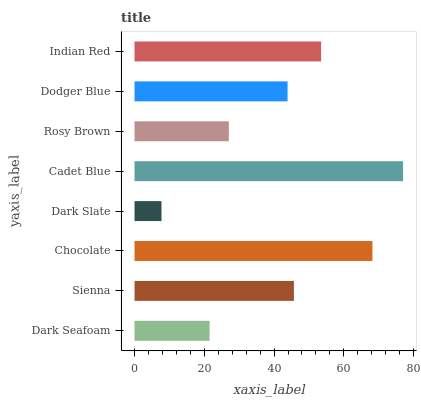Is Dark Slate the minimum?
Answer yes or no. Yes. Is Cadet Blue the maximum?
Answer yes or no. Yes. Is Sienna the minimum?
Answer yes or no. No. Is Sienna the maximum?
Answer yes or no. No. Is Sienna greater than Dark Seafoam?
Answer yes or no. Yes. Is Dark Seafoam less than Sienna?
Answer yes or no. Yes. Is Dark Seafoam greater than Sienna?
Answer yes or no. No. Is Sienna less than Dark Seafoam?
Answer yes or no. No. Is Sienna the high median?
Answer yes or no. Yes. Is Dodger Blue the low median?
Answer yes or no. Yes. Is Cadet Blue the high median?
Answer yes or no. No. Is Cadet Blue the low median?
Answer yes or no. No. 